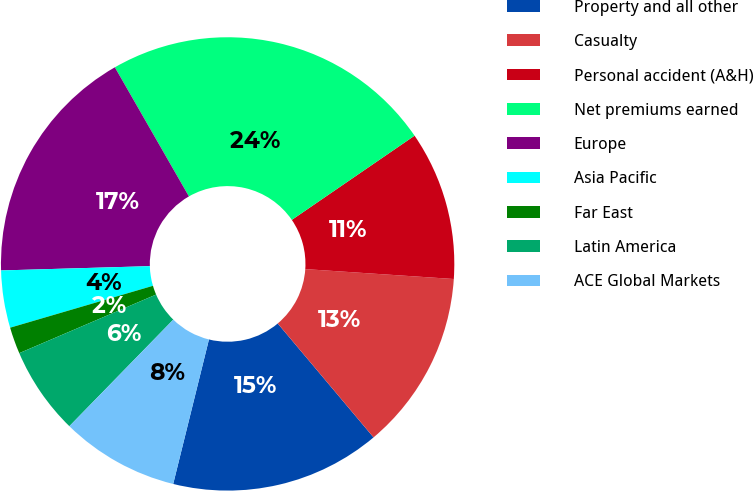Convert chart. <chart><loc_0><loc_0><loc_500><loc_500><pie_chart><fcel>Property and all other<fcel>Casualty<fcel>Personal accident (A&H)<fcel>Net premiums earned<fcel>Europe<fcel>Asia Pacific<fcel>Far East<fcel>Latin America<fcel>ACE Global Markets<nl><fcel>14.99%<fcel>12.81%<fcel>10.63%<fcel>23.72%<fcel>17.17%<fcel>4.08%<fcel>1.9%<fcel>6.26%<fcel>8.44%<nl></chart> 